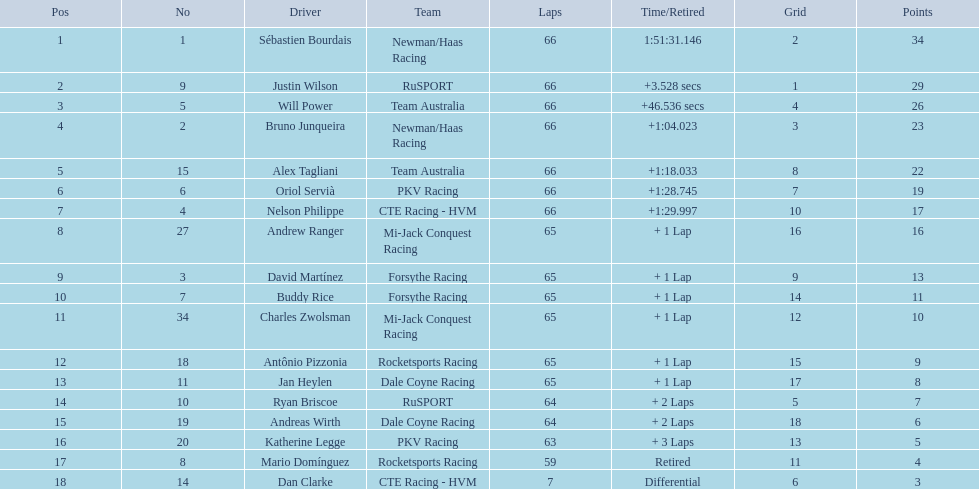Who are the drivers? Sébastien Bourdais, Justin Wilson, Will Power, Bruno Junqueira, Alex Tagliani, Oriol Servià, Nelson Philippe, Andrew Ranger, David Martínez, Buddy Rice, Charles Zwolsman, Antônio Pizzonia, Jan Heylen, Ryan Briscoe, Andreas Wirth, Katherine Legge, Mario Domínguez, Dan Clarke. What are their numbers? 1, 9, 5, 2, 15, 6, 4, 27, 3, 7, 34, 18, 11, 10, 19, 20, 8, 14. What are their positions? 1, 2, 3, 4, 5, 6, 7, 8, 9, 10, 11, 12, 13, 14, 15, 16, 17, 18. Which driver has the same number and position? Sébastien Bourdais. 